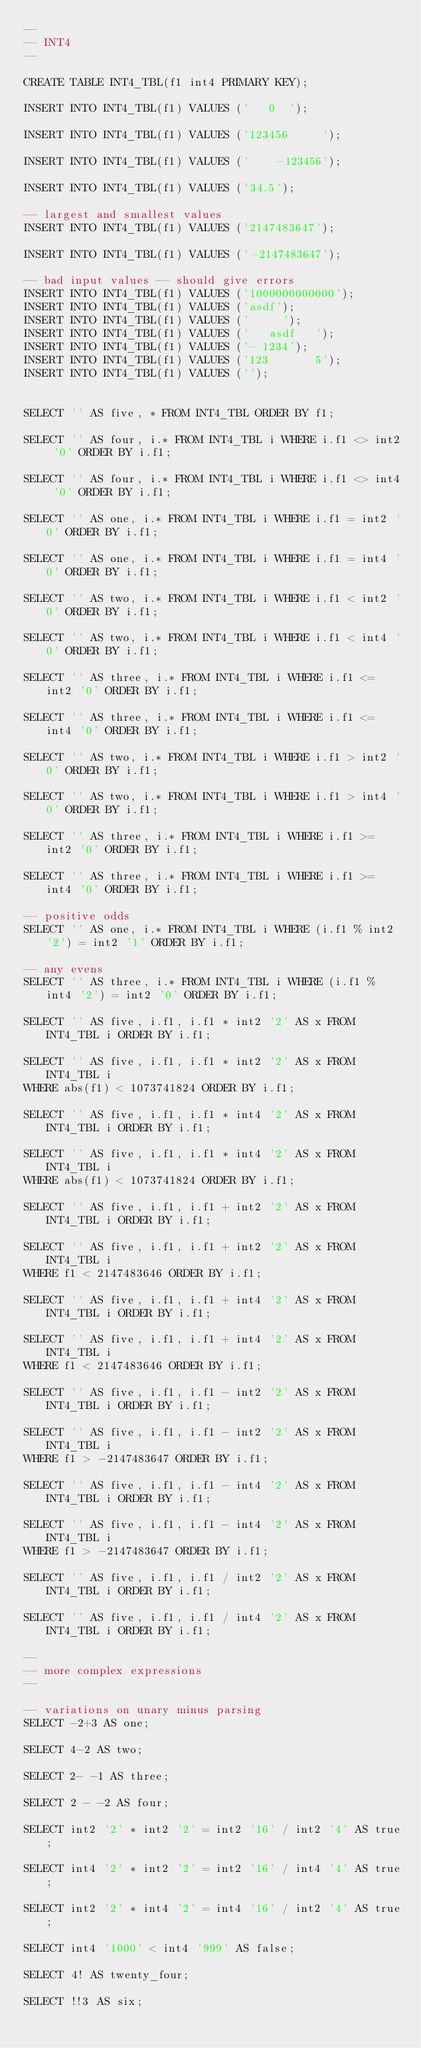<code> <loc_0><loc_0><loc_500><loc_500><_SQL_>--
-- INT4
--

CREATE TABLE INT4_TBL(f1 int4 PRIMARY KEY);

INSERT INTO INT4_TBL(f1) VALUES ('   0  ');

INSERT INTO INT4_TBL(f1) VALUES ('123456     ');

INSERT INTO INT4_TBL(f1) VALUES ('    -123456');

INSERT INTO INT4_TBL(f1) VALUES ('34.5');

-- largest and smallest values
INSERT INTO INT4_TBL(f1) VALUES ('2147483647');

INSERT INTO INT4_TBL(f1) VALUES ('-2147483647');

-- bad input values -- should give errors
INSERT INTO INT4_TBL(f1) VALUES ('1000000000000');
INSERT INTO INT4_TBL(f1) VALUES ('asdf');
INSERT INTO INT4_TBL(f1) VALUES ('     ');
INSERT INTO INT4_TBL(f1) VALUES ('   asdf   ');
INSERT INTO INT4_TBL(f1) VALUES ('- 1234');
INSERT INTO INT4_TBL(f1) VALUES ('123       5');
INSERT INTO INT4_TBL(f1) VALUES ('');


SELECT '' AS five, * FROM INT4_TBL ORDER BY f1;

SELECT '' AS four, i.* FROM INT4_TBL i WHERE i.f1 <> int2 '0' ORDER BY i.f1;

SELECT '' AS four, i.* FROM INT4_TBL i WHERE i.f1 <> int4 '0' ORDER BY i.f1;

SELECT '' AS one, i.* FROM INT4_TBL i WHERE i.f1 = int2 '0' ORDER BY i.f1;

SELECT '' AS one, i.* FROM INT4_TBL i WHERE i.f1 = int4 '0' ORDER BY i.f1;

SELECT '' AS two, i.* FROM INT4_TBL i WHERE i.f1 < int2 '0' ORDER BY i.f1;

SELECT '' AS two, i.* FROM INT4_TBL i WHERE i.f1 < int4 '0' ORDER BY i.f1;

SELECT '' AS three, i.* FROM INT4_TBL i WHERE i.f1 <= int2 '0' ORDER BY i.f1;

SELECT '' AS three, i.* FROM INT4_TBL i WHERE i.f1 <= int4 '0' ORDER BY i.f1;

SELECT '' AS two, i.* FROM INT4_TBL i WHERE i.f1 > int2 '0' ORDER BY i.f1;

SELECT '' AS two, i.* FROM INT4_TBL i WHERE i.f1 > int4 '0' ORDER BY i.f1;

SELECT '' AS three, i.* FROM INT4_TBL i WHERE i.f1 >= int2 '0' ORDER BY i.f1;

SELECT '' AS three, i.* FROM INT4_TBL i WHERE i.f1 >= int4 '0' ORDER BY i.f1;

-- positive odds
SELECT '' AS one, i.* FROM INT4_TBL i WHERE (i.f1 % int2 '2') = int2 '1' ORDER BY i.f1;

-- any evens
SELECT '' AS three, i.* FROM INT4_TBL i WHERE (i.f1 % int4 '2') = int2 '0' ORDER BY i.f1;

SELECT '' AS five, i.f1, i.f1 * int2 '2' AS x FROM INT4_TBL i ORDER BY i.f1;

SELECT '' AS five, i.f1, i.f1 * int2 '2' AS x FROM INT4_TBL i
WHERE abs(f1) < 1073741824 ORDER BY i.f1;

SELECT '' AS five, i.f1, i.f1 * int4 '2' AS x FROM INT4_TBL i ORDER BY i.f1;

SELECT '' AS five, i.f1, i.f1 * int4 '2' AS x FROM INT4_TBL i
WHERE abs(f1) < 1073741824 ORDER BY i.f1;

SELECT '' AS five, i.f1, i.f1 + int2 '2' AS x FROM INT4_TBL i ORDER BY i.f1;

SELECT '' AS five, i.f1, i.f1 + int2 '2' AS x FROM INT4_TBL i
WHERE f1 < 2147483646 ORDER BY i.f1;

SELECT '' AS five, i.f1, i.f1 + int4 '2' AS x FROM INT4_TBL i ORDER BY i.f1;

SELECT '' AS five, i.f1, i.f1 + int4 '2' AS x FROM INT4_TBL i
WHERE f1 < 2147483646 ORDER BY i.f1;

SELECT '' AS five, i.f1, i.f1 - int2 '2' AS x FROM INT4_TBL i ORDER BY i.f1;

SELECT '' AS five, i.f1, i.f1 - int2 '2' AS x FROM INT4_TBL i
WHERE f1 > -2147483647 ORDER BY i.f1;

SELECT '' AS five, i.f1, i.f1 - int4 '2' AS x FROM INT4_TBL i ORDER BY i.f1;

SELECT '' AS five, i.f1, i.f1 - int4 '2' AS x FROM INT4_TBL i
WHERE f1 > -2147483647 ORDER BY i.f1;

SELECT '' AS five, i.f1, i.f1 / int2 '2' AS x FROM INT4_TBL i ORDER BY i.f1;

SELECT '' AS five, i.f1, i.f1 / int4 '2' AS x FROM INT4_TBL i ORDER BY i.f1;

--
-- more complex expressions
--

-- variations on unary minus parsing
SELECT -2+3 AS one;

SELECT 4-2 AS two;

SELECT 2- -1 AS three;

SELECT 2 - -2 AS four;

SELECT int2 '2' * int2 '2' = int2 '16' / int2 '4' AS true;

SELECT int4 '2' * int2 '2' = int2 '16' / int4 '4' AS true;

SELECT int2 '2' * int4 '2' = int4 '16' / int2 '4' AS true;

SELECT int4 '1000' < int4 '999' AS false;

SELECT 4! AS twenty_four;

SELECT !!3 AS six;
</code> 